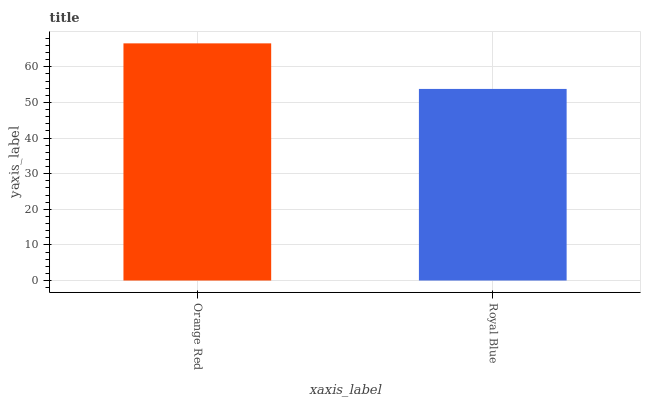Is Royal Blue the maximum?
Answer yes or no. No. Is Orange Red greater than Royal Blue?
Answer yes or no. Yes. Is Royal Blue less than Orange Red?
Answer yes or no. Yes. Is Royal Blue greater than Orange Red?
Answer yes or no. No. Is Orange Red less than Royal Blue?
Answer yes or no. No. Is Orange Red the high median?
Answer yes or no. Yes. Is Royal Blue the low median?
Answer yes or no. Yes. Is Royal Blue the high median?
Answer yes or no. No. Is Orange Red the low median?
Answer yes or no. No. 